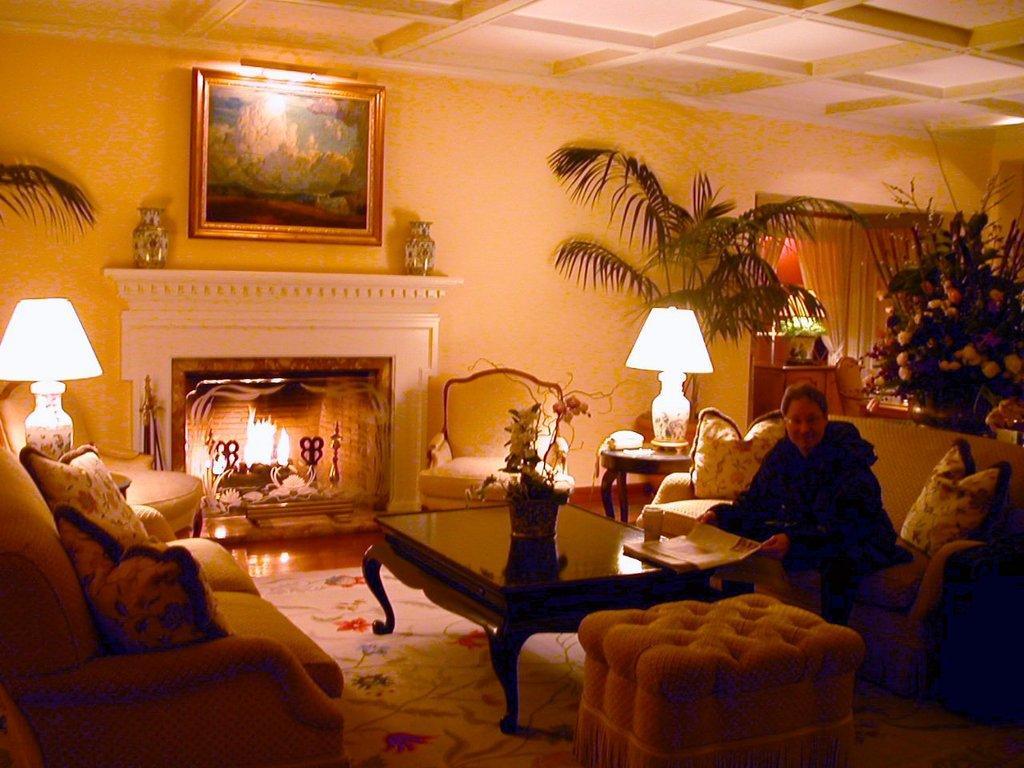Describe this image in one or two sentences. In this image I can see few sofas and numbers of cushions on it. I can also see a person is sitting on a sofa. Here on this table I can see a plant. In the background I can see two lamps, few more plants and a frame on this wall. 